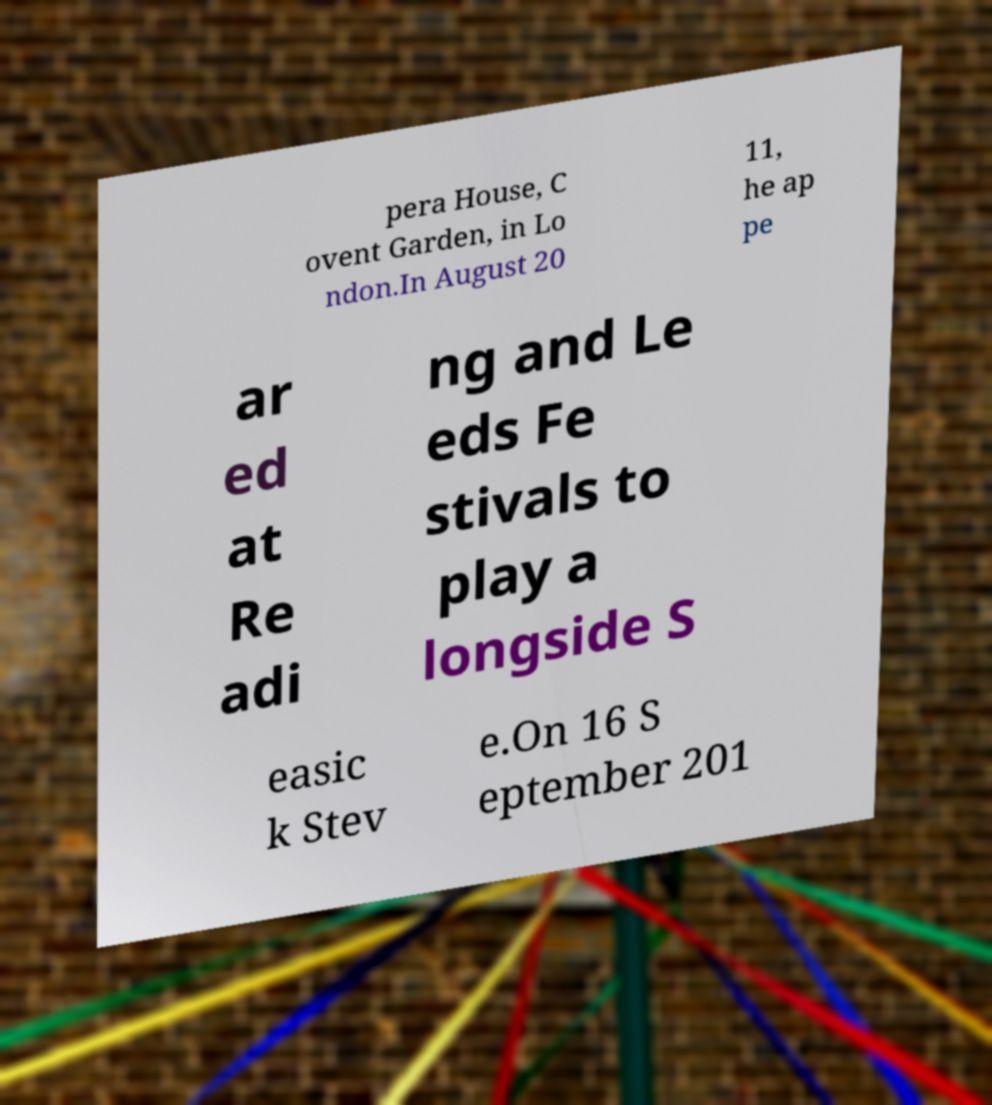Could you extract and type out the text from this image? pera House, C ovent Garden, in Lo ndon.In August 20 11, he ap pe ar ed at Re adi ng and Le eds Fe stivals to play a longside S easic k Stev e.On 16 S eptember 201 